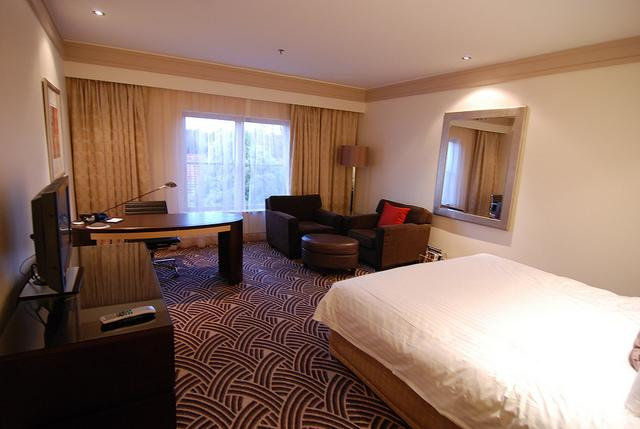The pillow on the couch is the same color as what? red 